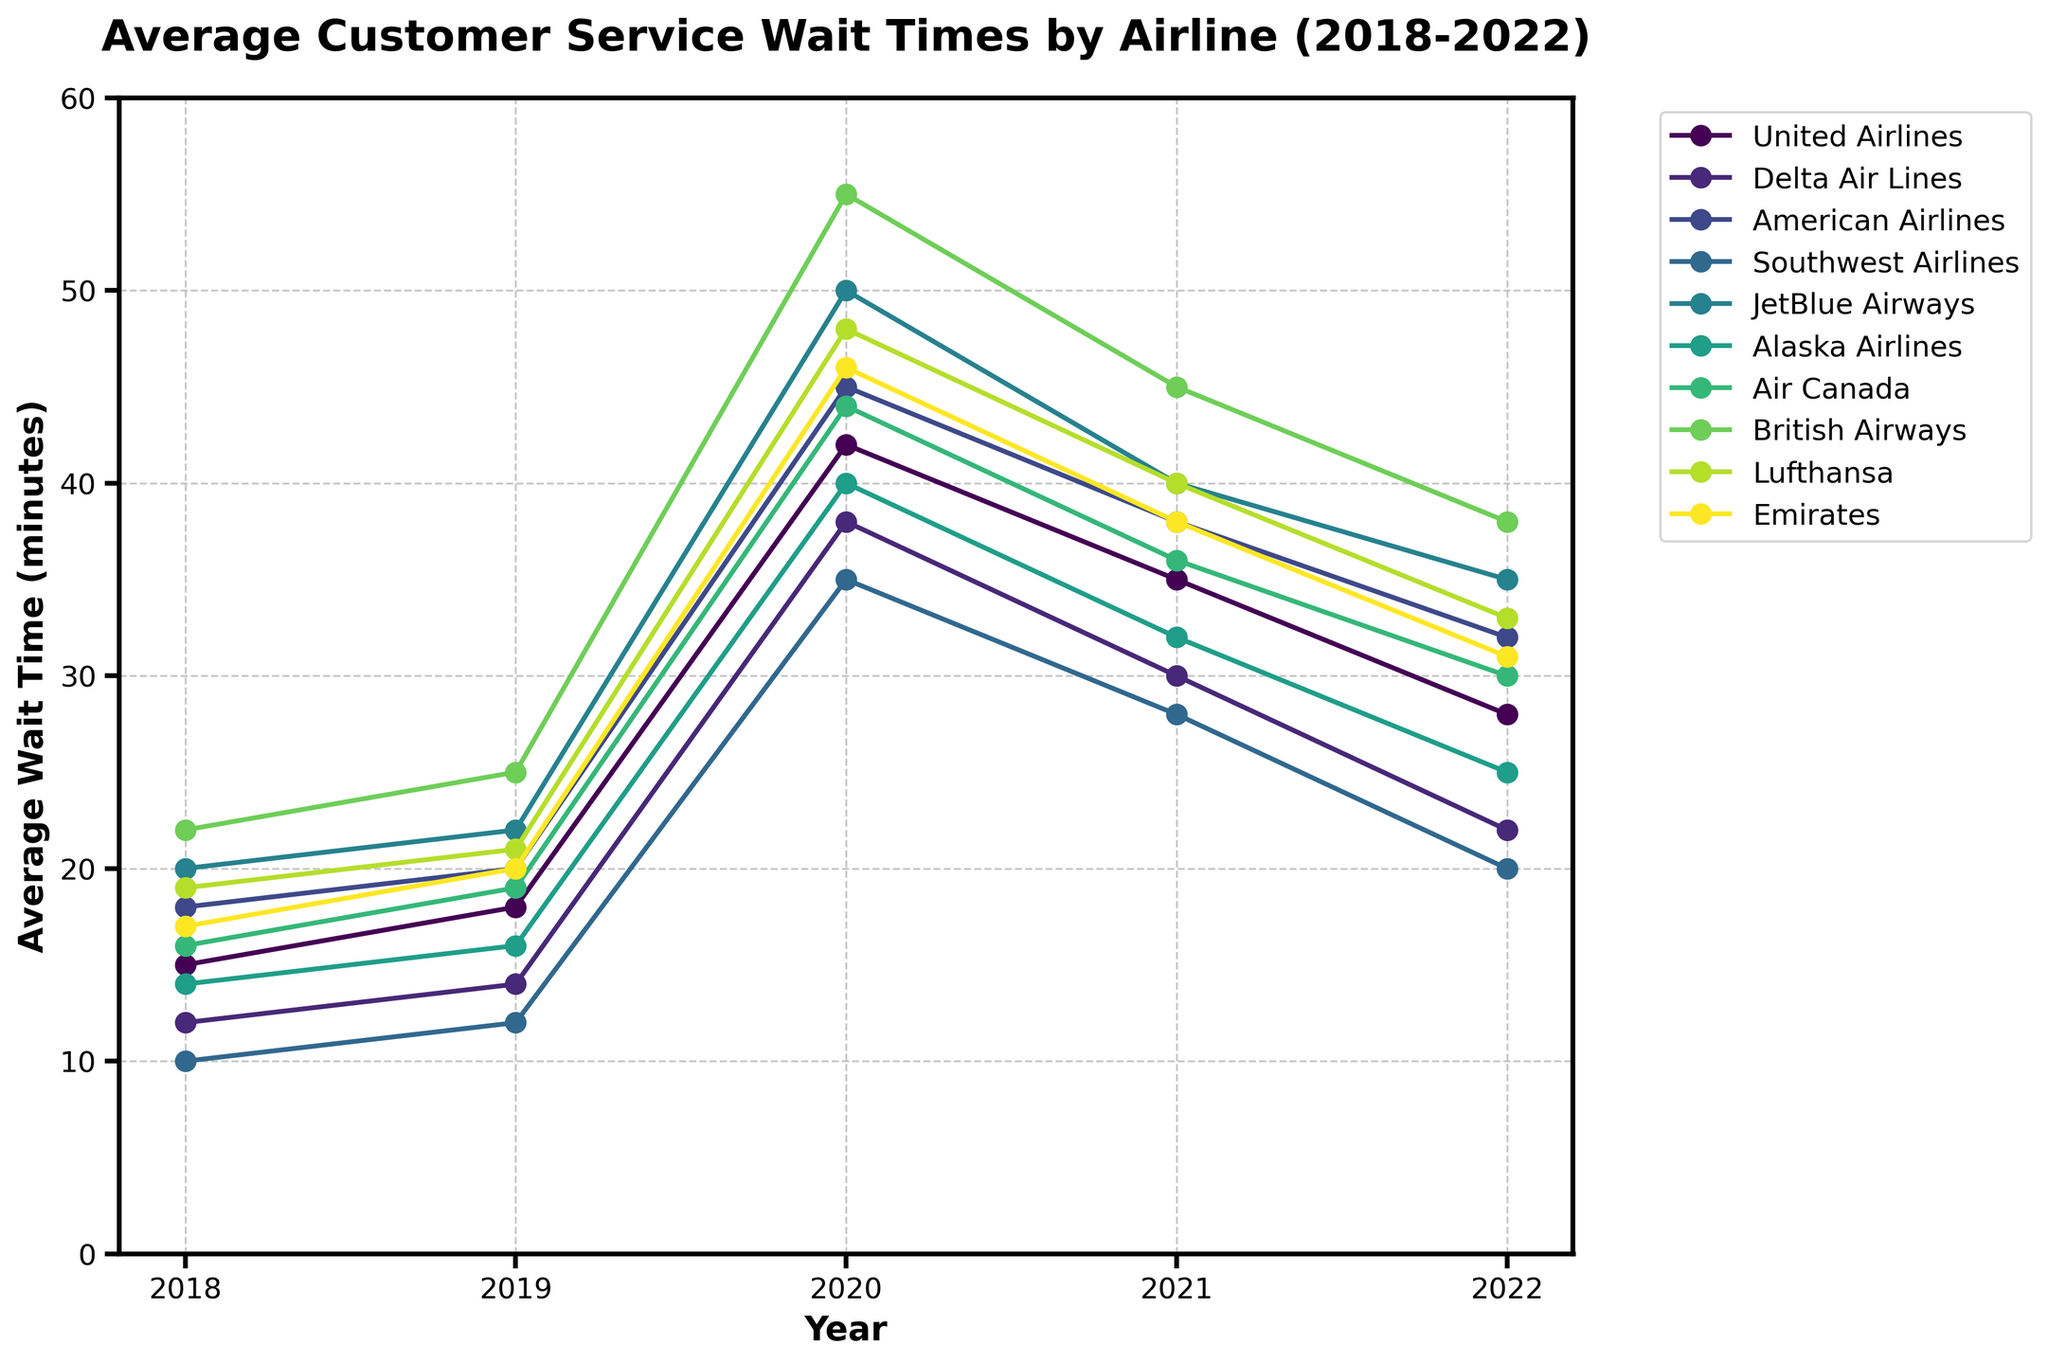Which airline had the longest average wait time in 2022? The longest average wait time in 2022 can be identified by looking at the highest data point for that year. The highest point is for British Airways at 38 minutes.
Answer: British Airways How much did the average wait time for American Airlines increase from 2018 to 2020? Compare the wait times for American Airlines in 2018 and 2020. In 2018, it was 18 minutes, and in 2020, it was 45 minutes. The difference is 45 - 18 = 27 minutes.
Answer: 27 minutes Which airline experienced the largest decrease in average wait times from 2020 to 2022? Compare the data points from 2020 to 2022 for each airline to see which has the largest drop. United Airlines dropped from 42 to 28, Delta from 38 to 22, American from 45 to 32, Southwest from 35 to 20, JetBlue from 50 to 35, Alaska from 40 to 25, Air Canada from 44 to 30, British from 55 to 38, Lufthansa from 48 to 33, and Emirates from 46 to 31. The largest decrease is for British Airways (55 - 38 = 17).
Answer: British Airways What is the overall trend in average wait times for Emirates from 2018 to 2022? Look at the data points for Emirates over the years: 2018 (17), 2019 (20), 2020 (46), 2021 (38), 2022 (31). The trend shows an initial increase from 2018 to 2020, followed by a decrease from 2020 to 2022.
Answer: Initial increase, then decrease In which year did JetBlue Airways see its highest average wait time, and what was that time? Identify the highest data point for JetBlue Airways across all years. The highest point is in 2020 with a wait time of 50 minutes.
Answer: 2020, 50 minutes How does the average wait time for Southwest Airlines in 2022 compare to Alaska Airlines in the same year? Compare the 2022 data points for Southwest Airlines and Alaska Airlines. Southwest's average wait time is 20 minutes, and Alaska's is 25 minutes. Hence, Southwest has a shorter wait time.
Answer: Southwest Airlines has a shorter wait time What is the difference in average wait times between Delta Air Lines and Air Canada in 2021? Compare the data points for 2021: Delta Air Lines had 30 minutes, and Air Canada had 36 minutes. The difference is 36 - 30 = 6 minutes.
Answer: 6 minutes Which airlines had a consistently increasing trend in average wait times each year from 2018 to 2022? Evaluate the data for each airline to determine which had an increasing trend. No airline has a consistent increasing trend each year; all airlines show some decrease at certain points.
Answer: None 